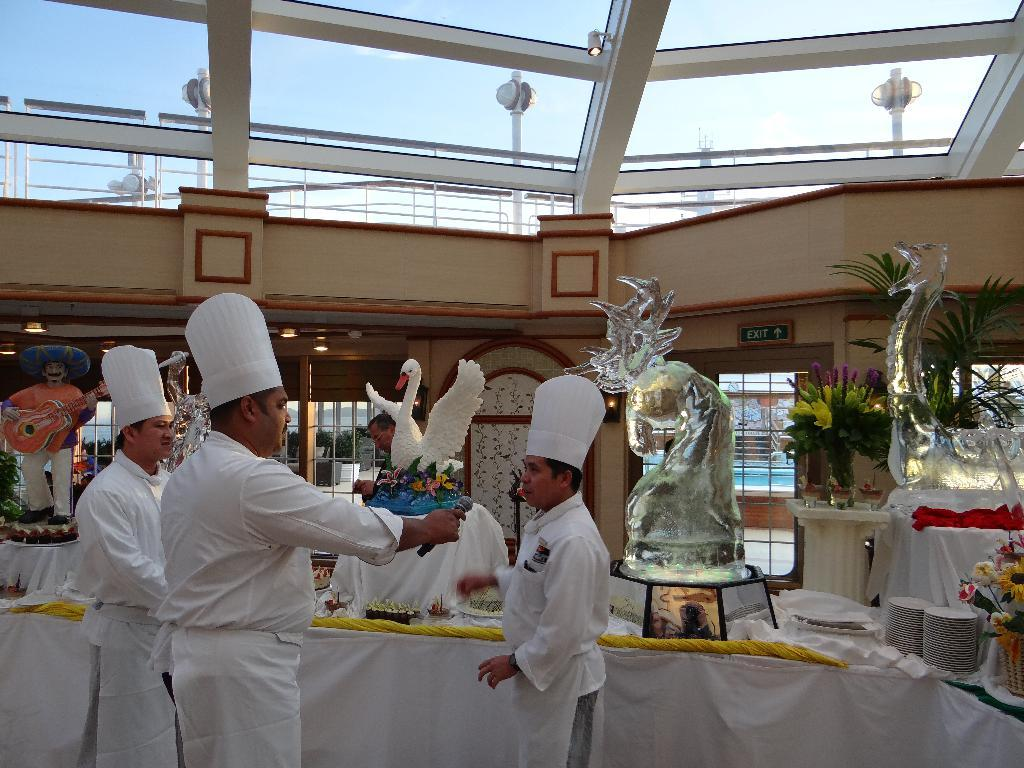What type of structure is visible in the image? There is a building in the image. What is attached to the building in the image? There is a sign board in the image. What type of artistic creations can be seen in the image? There are ice sculptures in the image. What are the people in the image doing? There are persons standing on the floor in the image. What items might be used for serving food in the image? Serving plates are visible in the image. What type of decorative objects are present in the image? Flower vases and decors are present in the image. What type of protective covering is visible in the image? Polythene covers are in the image. What type of plough can be seen in the image? There is no plough present in the image. What type of jelly is being served on the plates in the image? There is no jelly visible in the image; only serving plates are mentioned. 